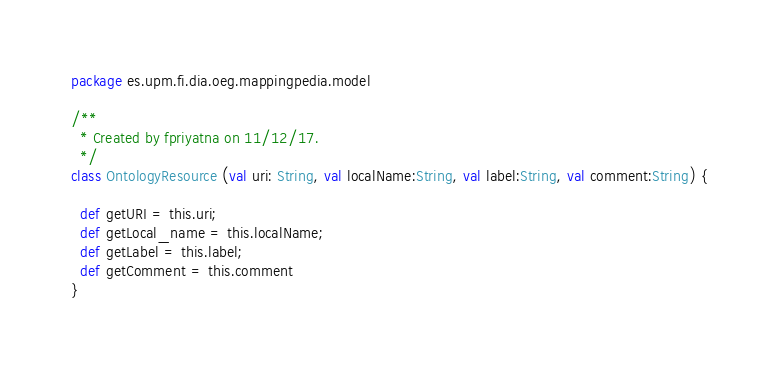<code> <loc_0><loc_0><loc_500><loc_500><_Scala_>package es.upm.fi.dia.oeg.mappingpedia.model

/**
  * Created by fpriyatna on 11/12/17.
  */
class OntologyResource (val uri: String, val localName:String, val label:String, val comment:String) {

  def getURI = this.uri;
  def getLocal_name = this.localName;
  def getLabel = this.label;
  def getComment = this.comment
}
</code> 